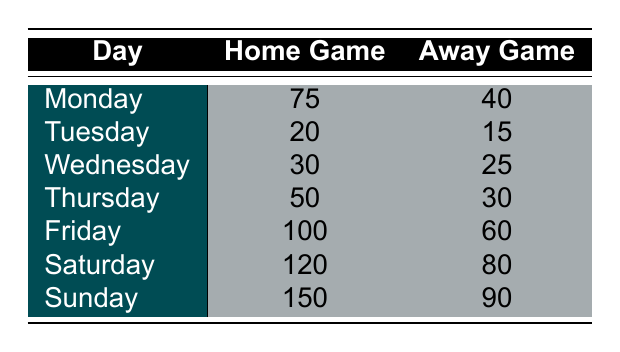What is the highest customer visit count for Home Games? Looking at the Home Game column, the maximum value is 150 on Sunday.
Answer: 150 On which day do the Away Games have the least customer visits? By examining the Away Game column, Tuesday has the lowest value of 15 customer visits.
Answer: Tuesday What is the total number of customer visits for Home Games across all days of the week? We sum the values in the Home Game column: 75 + 20 + 30 + 50 + 100 + 120 + 150 = 545.
Answer: 545 Is the customer visit count higher on Home Games than Away Games for Saturdays? Referring to the Saturday row, Home Games have 120 visits while Away Games have 80 visits, so Home Games are higher.
Answer: Yes What is the average number of customer visits for Away Games? We first calculate the total visits for Away Games: 40 + 15 + 25 + 30 + 60 + 80 + 90 = 350. There are 7 days, so the average is 350 / 7 = 50.
Answer: 50 Which day has the greatest difference in customer visits between Home Game and Away Game? We calculate differences: Monday (35), Tuesday (5), Wednesday (5), Thursday (20), Friday (40), Saturday (40), Sunday (60). The maximum difference is 60 on Sunday.
Answer: Sunday Are there more customer visits for Home Games or Away Games on Fridays? Comparing Friday visits, Home Games have 100 and Away Games have 60. Home Games have more visits.
Answer: Home Games What is the total customer visit count for both Home and Away Games on Sundays? The sum for Sunday is Home Games (150) + Away Games (90) = 240.
Answer: 240 